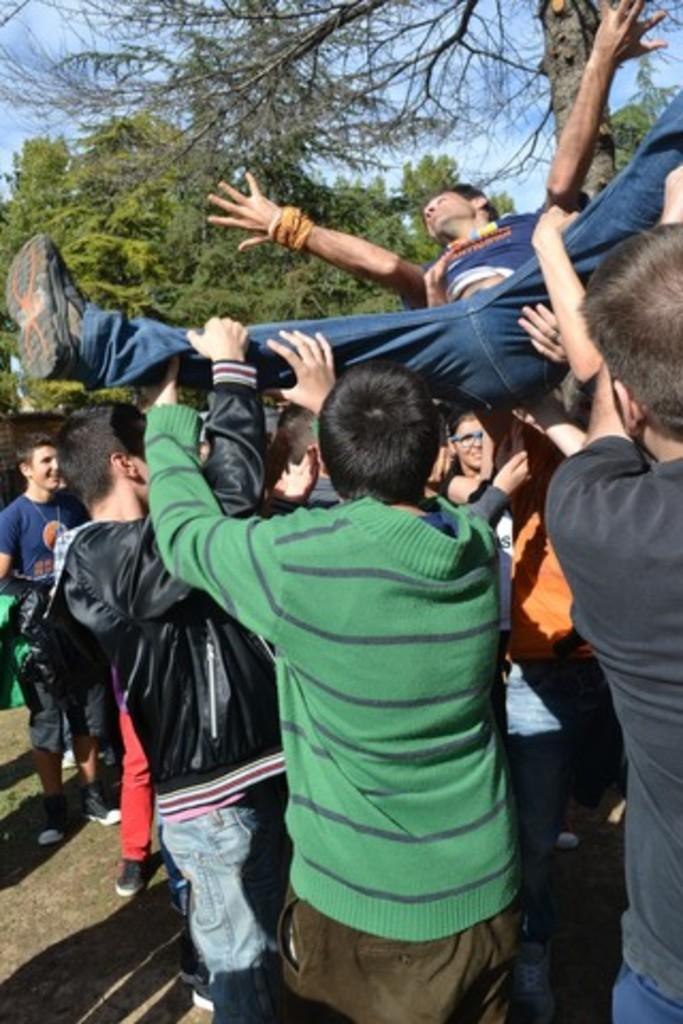How many people are in the image? There is a group of people in the image. What are the people in the image doing? The people are standing on the ground and holding a person. What can be seen in the background of the image? There are trees and the sky visible in the background of the image. What type of route can be seen in the image? There is no route visible in the image; it features a group of people standing on the ground and holding a person, with trees and the sky in the background. Can you tell me the color of the tiger in the image? There is no tiger present in the image. 